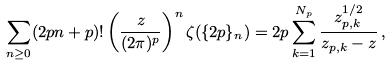Convert formula to latex. <formula><loc_0><loc_0><loc_500><loc_500>\sum _ { n \geq 0 } ( 2 p n + p ) ! \left ( \frac { z } { ( 2 \pi ) ^ { p } } \right ) ^ { n } \zeta ( \{ 2 p \} _ { n } ) = 2 p \sum _ { k = 1 } ^ { N _ { p } } \frac { z _ { p , k } ^ { 1 / 2 } } { z _ { p , k } - z } \, ,</formula> 